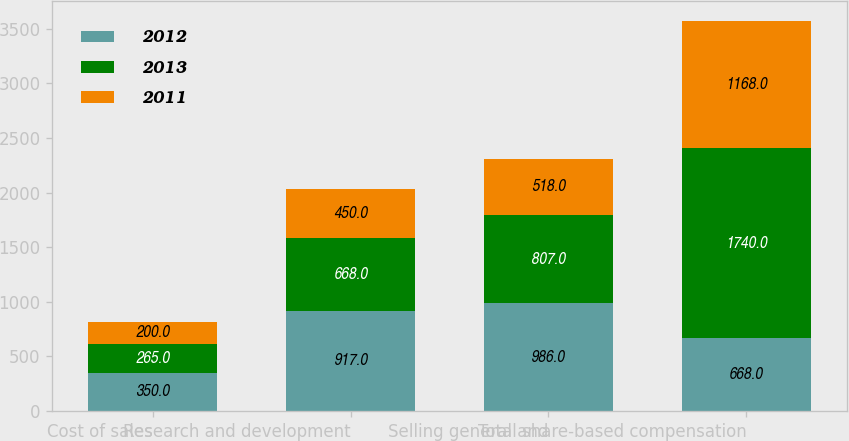<chart> <loc_0><loc_0><loc_500><loc_500><stacked_bar_chart><ecel><fcel>Cost of sales<fcel>Research and development<fcel>Selling general and<fcel>Total share-based compensation<nl><fcel>2012<fcel>350<fcel>917<fcel>986<fcel>668<nl><fcel>2013<fcel>265<fcel>668<fcel>807<fcel>1740<nl><fcel>2011<fcel>200<fcel>450<fcel>518<fcel>1168<nl></chart> 